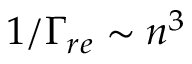<formula> <loc_0><loc_0><loc_500><loc_500>1 / \Gamma _ { r e } \sim n ^ { 3 }</formula> 